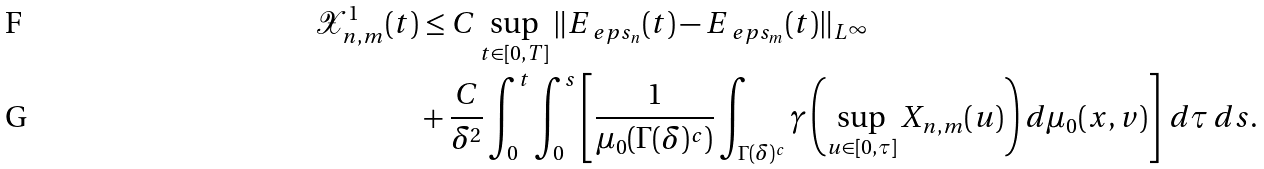Convert formula to latex. <formula><loc_0><loc_0><loc_500><loc_500>\mathcal { X } _ { n , m } ^ { 1 } ( t ) & \leq C \sup _ { t \in [ 0 , T ] } \| E _ { \ e p s _ { n } } ( t ) - E _ { \ e p s _ { m } } ( t ) \| _ { L ^ { \infty } } \\ & + \frac { C } { \delta ^ { 2 } } \int _ { 0 } ^ { t } \int _ { 0 } ^ { s } \left [ \frac { 1 } { \mu _ { 0 } ( \Gamma ( \delta ) ^ { c } ) } \int _ { \Gamma ( \delta ) ^ { c } } \gamma \left ( \sup _ { u \in [ 0 , \tau ] } X _ { n , m } ( u ) \right ) d \mu _ { 0 } ( x , v ) \right ] \, d \tau \, d s .</formula> 